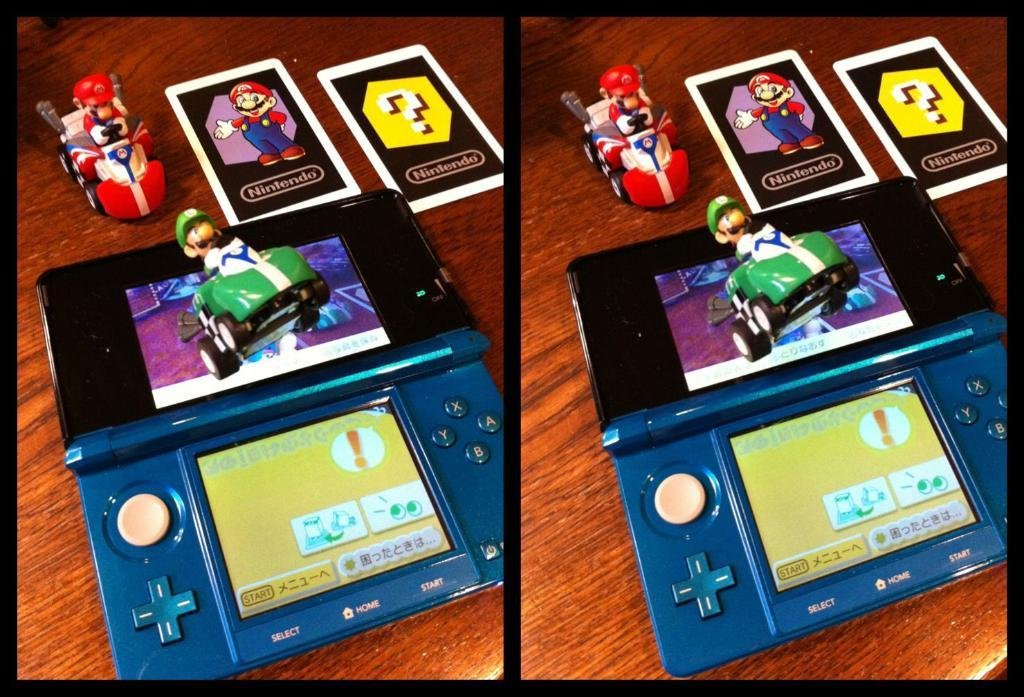What is the main subject in the first image? In the first image, there is a video game player. What other items can be seen in the first image? In the first image, there are two toys and two cards. Where are these items located in the first image? In the first image, these items are on a platform. Are the same elements present in the second image? Yes, in the second image, the same elements (video game player, two toys, and two cards) are present. Where are these items located in the second image? In the second image, these items are also on a platform. What type of camp can be seen in the background of the first image? There is no camp visible in the background of the first image. 